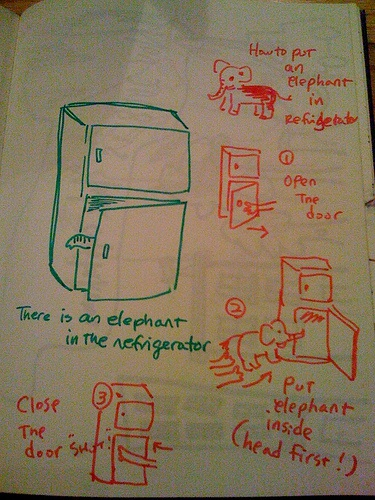Describe the objects in this image and their specific colors. I can see a refrigerator in maroon, gray, and darkgreen tones in this image. 